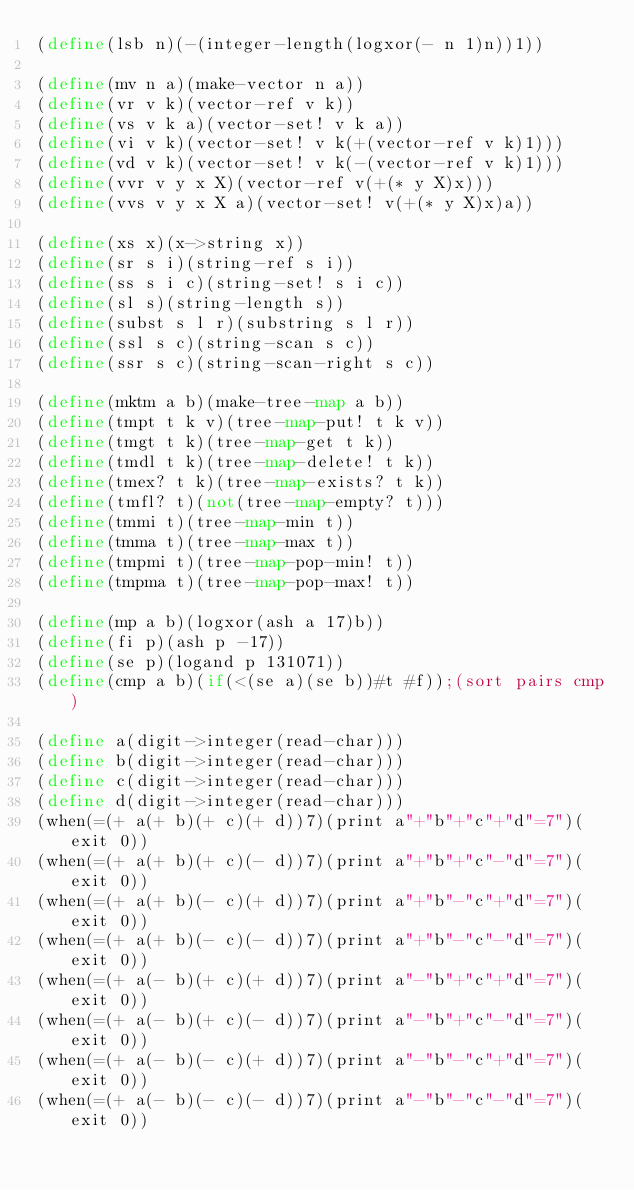Convert code to text. <code><loc_0><loc_0><loc_500><loc_500><_Scheme_>(define(lsb n)(-(integer-length(logxor(- n 1)n))1))

(define(mv n a)(make-vector n a))
(define(vr v k)(vector-ref v k))
(define(vs v k a)(vector-set! v k a))
(define(vi v k)(vector-set! v k(+(vector-ref v k)1)))
(define(vd v k)(vector-set! v k(-(vector-ref v k)1)))
(define(vvr v y x X)(vector-ref v(+(* y X)x)))
(define(vvs v y x X a)(vector-set! v(+(* y X)x)a))

(define(xs x)(x->string x))
(define(sr s i)(string-ref s i))
(define(ss s i c)(string-set! s i c))
(define(sl s)(string-length s))
(define(subst s l r)(substring s l r))
(define(ssl s c)(string-scan s c))
(define(ssr s c)(string-scan-right s c))

(define(mktm a b)(make-tree-map a b))
(define(tmpt t k v)(tree-map-put! t k v))
(define(tmgt t k)(tree-map-get t k))
(define(tmdl t k)(tree-map-delete! t k))
(define(tmex? t k)(tree-map-exists? t k))
(define(tmfl? t)(not(tree-map-empty? t)))
(define(tmmi t)(tree-map-min t))
(define(tmma t)(tree-map-max t))
(define(tmpmi t)(tree-map-pop-min! t))
(define(tmpma t)(tree-map-pop-max! t))

(define(mp a b)(logxor(ash a 17)b))
(define(fi p)(ash p -17))
(define(se p)(logand p 131071))
(define(cmp a b)(if(<(se a)(se b))#t #f));(sort pairs cmp)

(define a(digit->integer(read-char)))
(define b(digit->integer(read-char)))
(define c(digit->integer(read-char)))
(define d(digit->integer(read-char)))
(when(=(+ a(+ b)(+ c)(+ d))7)(print a"+"b"+"c"+"d"=7")(exit 0))
(when(=(+ a(+ b)(+ c)(- d))7)(print a"+"b"+"c"-"d"=7")(exit 0))
(when(=(+ a(+ b)(- c)(+ d))7)(print a"+"b"-"c"+"d"=7")(exit 0))
(when(=(+ a(+ b)(- c)(- d))7)(print a"+"b"-"c"-"d"=7")(exit 0))
(when(=(+ a(- b)(+ c)(+ d))7)(print a"-"b"+"c"+"d"=7")(exit 0))
(when(=(+ a(- b)(+ c)(- d))7)(print a"-"b"+"c"-"d"=7")(exit 0))
(when(=(+ a(- b)(- c)(+ d))7)(print a"-"b"-"c"+"d"=7")(exit 0))
(when(=(+ a(- b)(- c)(- d))7)(print a"-"b"-"c"-"d"=7")(exit 0))</code> 